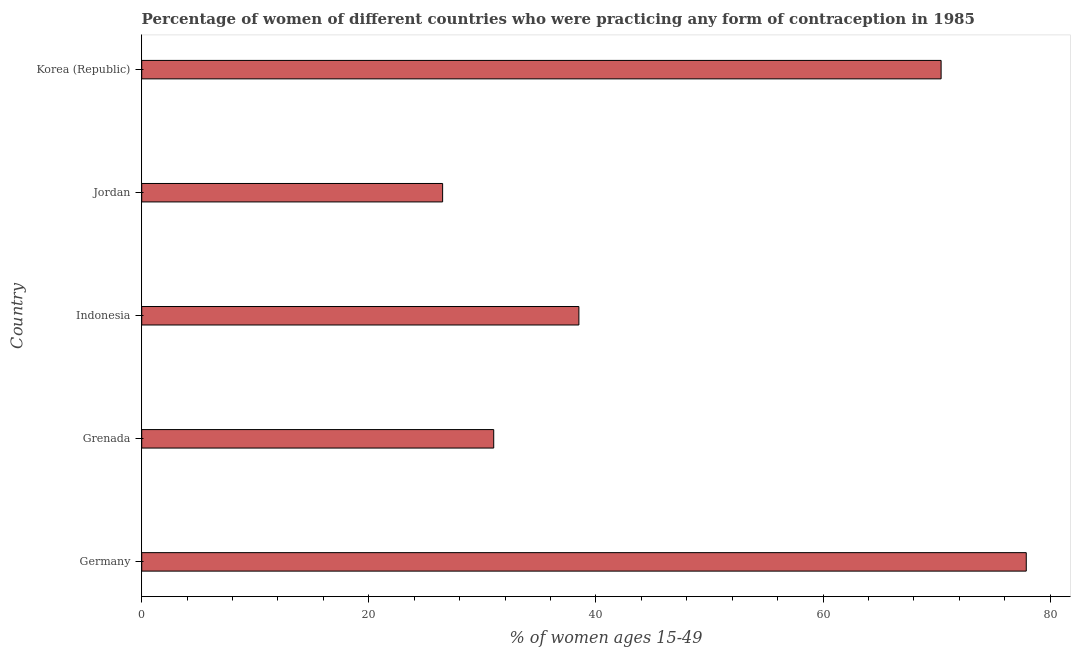Does the graph contain any zero values?
Ensure brevity in your answer.  No. Does the graph contain grids?
Provide a succinct answer. No. What is the title of the graph?
Provide a succinct answer. Percentage of women of different countries who were practicing any form of contraception in 1985. What is the label or title of the X-axis?
Offer a very short reply. % of women ages 15-49. What is the contraceptive prevalence in Indonesia?
Provide a succinct answer. 38.5. Across all countries, what is the maximum contraceptive prevalence?
Provide a succinct answer. 77.9. Across all countries, what is the minimum contraceptive prevalence?
Ensure brevity in your answer.  26.5. In which country was the contraceptive prevalence minimum?
Keep it short and to the point. Jordan. What is the sum of the contraceptive prevalence?
Your answer should be very brief. 244.3. What is the difference between the contraceptive prevalence in Germany and Indonesia?
Offer a very short reply. 39.4. What is the average contraceptive prevalence per country?
Offer a terse response. 48.86. What is the median contraceptive prevalence?
Offer a very short reply. 38.5. What is the ratio of the contraceptive prevalence in Grenada to that in Indonesia?
Keep it short and to the point. 0.81. Is the difference between the contraceptive prevalence in Germany and Jordan greater than the difference between any two countries?
Your response must be concise. Yes. What is the difference between the highest and the second highest contraceptive prevalence?
Provide a short and direct response. 7.5. Is the sum of the contraceptive prevalence in Germany and Indonesia greater than the maximum contraceptive prevalence across all countries?
Ensure brevity in your answer.  Yes. What is the difference between the highest and the lowest contraceptive prevalence?
Provide a succinct answer. 51.4. How many bars are there?
Ensure brevity in your answer.  5. How many countries are there in the graph?
Ensure brevity in your answer.  5. What is the difference between two consecutive major ticks on the X-axis?
Your answer should be compact. 20. What is the % of women ages 15-49 in Germany?
Your answer should be compact. 77.9. What is the % of women ages 15-49 in Grenada?
Provide a succinct answer. 31. What is the % of women ages 15-49 of Indonesia?
Provide a succinct answer. 38.5. What is the % of women ages 15-49 of Jordan?
Ensure brevity in your answer.  26.5. What is the % of women ages 15-49 of Korea (Republic)?
Your response must be concise. 70.4. What is the difference between the % of women ages 15-49 in Germany and Grenada?
Offer a very short reply. 46.9. What is the difference between the % of women ages 15-49 in Germany and Indonesia?
Provide a short and direct response. 39.4. What is the difference between the % of women ages 15-49 in Germany and Jordan?
Your answer should be very brief. 51.4. What is the difference between the % of women ages 15-49 in Germany and Korea (Republic)?
Keep it short and to the point. 7.5. What is the difference between the % of women ages 15-49 in Grenada and Indonesia?
Your response must be concise. -7.5. What is the difference between the % of women ages 15-49 in Grenada and Jordan?
Offer a terse response. 4.5. What is the difference between the % of women ages 15-49 in Grenada and Korea (Republic)?
Keep it short and to the point. -39.4. What is the difference between the % of women ages 15-49 in Indonesia and Korea (Republic)?
Your answer should be compact. -31.9. What is the difference between the % of women ages 15-49 in Jordan and Korea (Republic)?
Provide a succinct answer. -43.9. What is the ratio of the % of women ages 15-49 in Germany to that in Grenada?
Keep it short and to the point. 2.51. What is the ratio of the % of women ages 15-49 in Germany to that in Indonesia?
Your answer should be very brief. 2.02. What is the ratio of the % of women ages 15-49 in Germany to that in Jordan?
Provide a succinct answer. 2.94. What is the ratio of the % of women ages 15-49 in Germany to that in Korea (Republic)?
Ensure brevity in your answer.  1.11. What is the ratio of the % of women ages 15-49 in Grenada to that in Indonesia?
Ensure brevity in your answer.  0.81. What is the ratio of the % of women ages 15-49 in Grenada to that in Jordan?
Offer a very short reply. 1.17. What is the ratio of the % of women ages 15-49 in Grenada to that in Korea (Republic)?
Your answer should be compact. 0.44. What is the ratio of the % of women ages 15-49 in Indonesia to that in Jordan?
Provide a short and direct response. 1.45. What is the ratio of the % of women ages 15-49 in Indonesia to that in Korea (Republic)?
Your answer should be compact. 0.55. What is the ratio of the % of women ages 15-49 in Jordan to that in Korea (Republic)?
Ensure brevity in your answer.  0.38. 